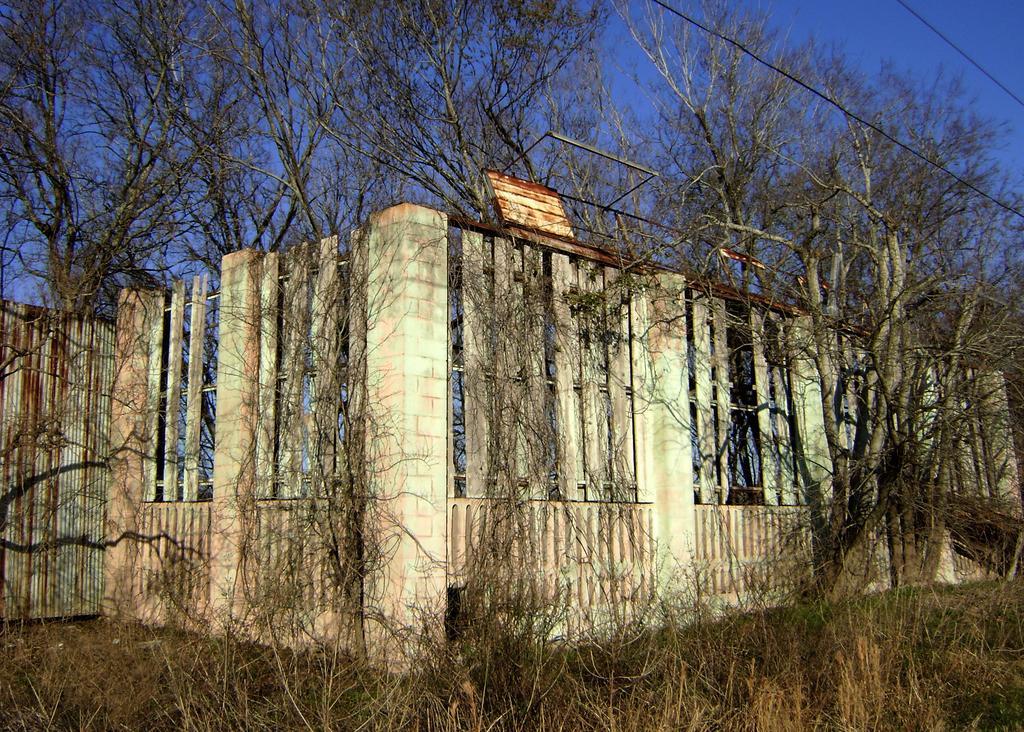Please provide a concise description of this image. In this picture there is a boundary in the center of the image and there is greenery in the image. 